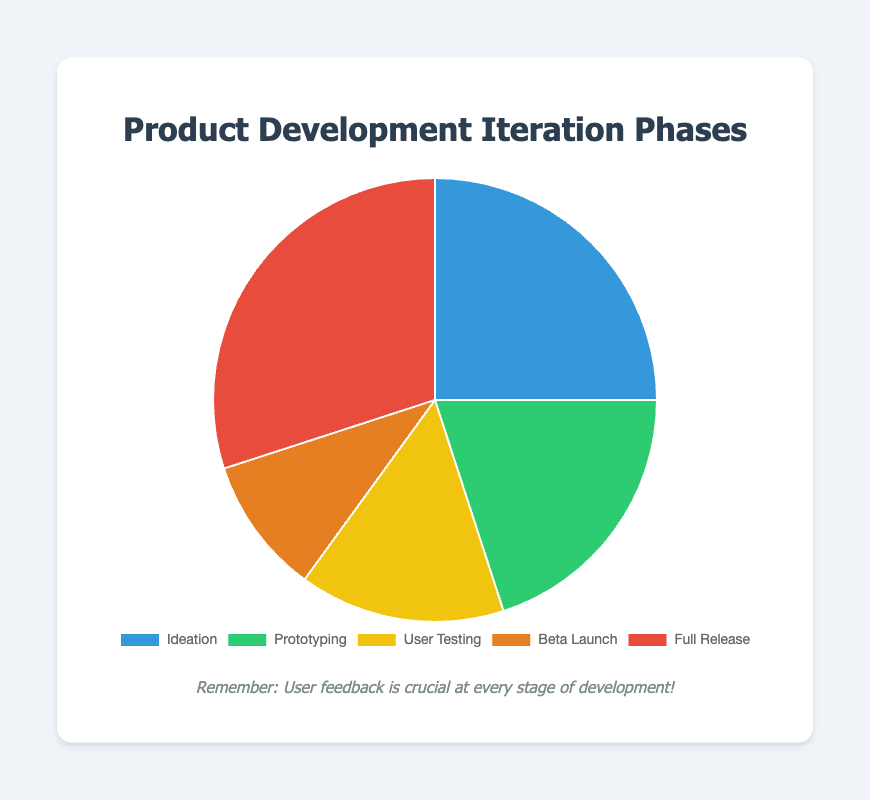What is the phase with the highest percentage? The Full Release phase has the highest value at 30%, which is visually evident as it takes up the largest portion of the pie chart.
Answer: Full Release Which phase has the smallest percentage? The Beta Launch phase has the smallest value at 10%, which is visually evident as it takes up the smallest portion of the pie chart.
Answer: Beta Launch What are the total percentages of the Ideation and Prototyping phases combined? Sum the percentages of Ideation (25%) and Prototyping (20%). 25% + 20% = 45%
Answer: 45% How does the percentage of the User Testing phase compare to the Beta Launch phase? The percentage of User Testing is 15%, and Beta Launch is 10%. 15% is greater than 10%.
Answer: User Testing > Beta Launch What is the average percentage of all the phases? Sum all percentages (25% + 20% + 15% + 10% + 30% = 100%) and divide by the number of phases (5). 100% / 5 = 20%
Answer: 20% What is the difference in percentage between the largest and smallest phases? The largest phase (Full Release) is 30%, and the smallest phase (Beta Launch) is 10%. 30% - 10% = 20%
Answer: 20% Which phases have percentages that sum up to more than half of the total percentage? Identify combinations where the sum exceeds 50%. The phases with Ideation (25%) and Full Release (30%) give 25% + 30% = 55%, and the same applies for any group including Full Release and Ideation whose percentages collectively exceed 50%.
Answer: Ideation and Full Release (and other similar combinations) Which color on the pie chart corresponds to the Prototyping phase? The color associated with the Prototyping phase is green.
Answer: Green Is the percentage of the Full Release phase more than double the percentage of the User Testing phase? The Full Release phase is 30%, and User Testing is 15%. 30% is exactly double of 15%, not more.
Answer: No How do the combined percentages of the User Testing and Beta Launch phases compare to the Full Release phase? Sum the percentages of User Testing (15%) and Beta Launch (10%). 15% + 10% = 25%. Compare this sum to Full Release (30%). 25% is less than 30%.
Answer: Less 